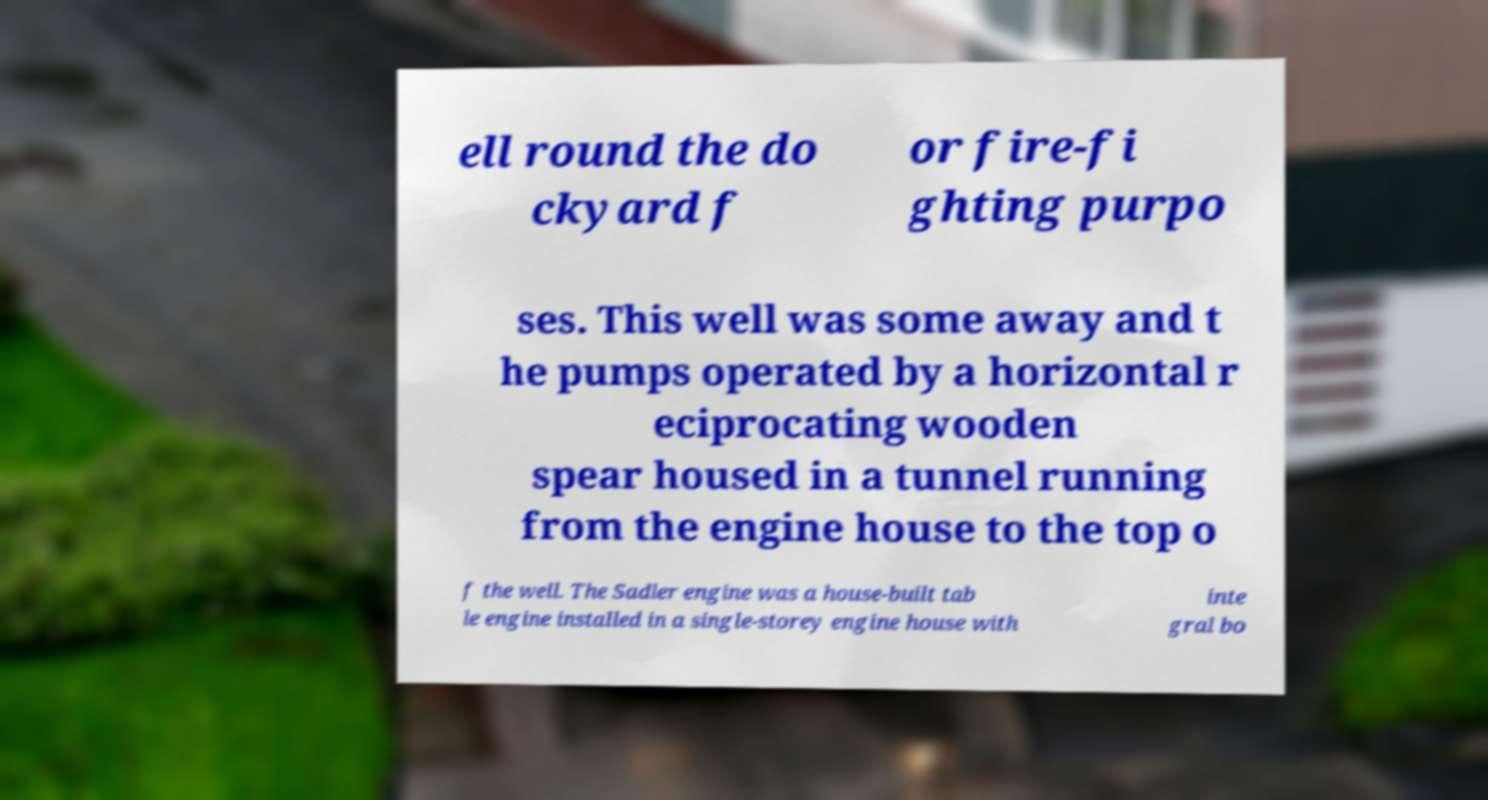What messages or text are displayed in this image? I need them in a readable, typed format. ell round the do ckyard f or fire-fi ghting purpo ses. This well was some away and t he pumps operated by a horizontal r eciprocating wooden spear housed in a tunnel running from the engine house to the top o f the well. The Sadler engine was a house-built tab le engine installed in a single-storey engine house with inte gral bo 